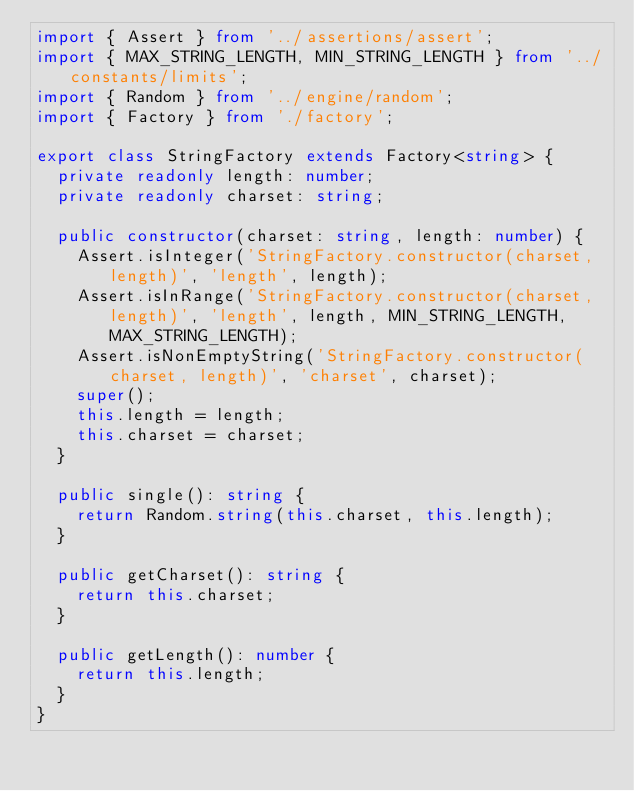<code> <loc_0><loc_0><loc_500><loc_500><_TypeScript_>import { Assert } from '../assertions/assert';
import { MAX_STRING_LENGTH, MIN_STRING_LENGTH } from '../constants/limits';
import { Random } from '../engine/random';
import { Factory } from './factory';

export class StringFactory extends Factory<string> {
  private readonly length: number;
  private readonly charset: string;

  public constructor(charset: string, length: number) {
    Assert.isInteger('StringFactory.constructor(charset, length)', 'length', length);
    Assert.isInRange('StringFactory.constructor(charset, length)', 'length', length, MIN_STRING_LENGTH, MAX_STRING_LENGTH);
    Assert.isNonEmptyString('StringFactory.constructor(charset, length)', 'charset', charset);
    super();
    this.length = length;
    this.charset = charset;
  }

  public single(): string {
    return Random.string(this.charset, this.length);
  }

  public getCharset(): string {
    return this.charset;
  }

  public getLength(): number {
    return this.length;
  }
}
</code> 